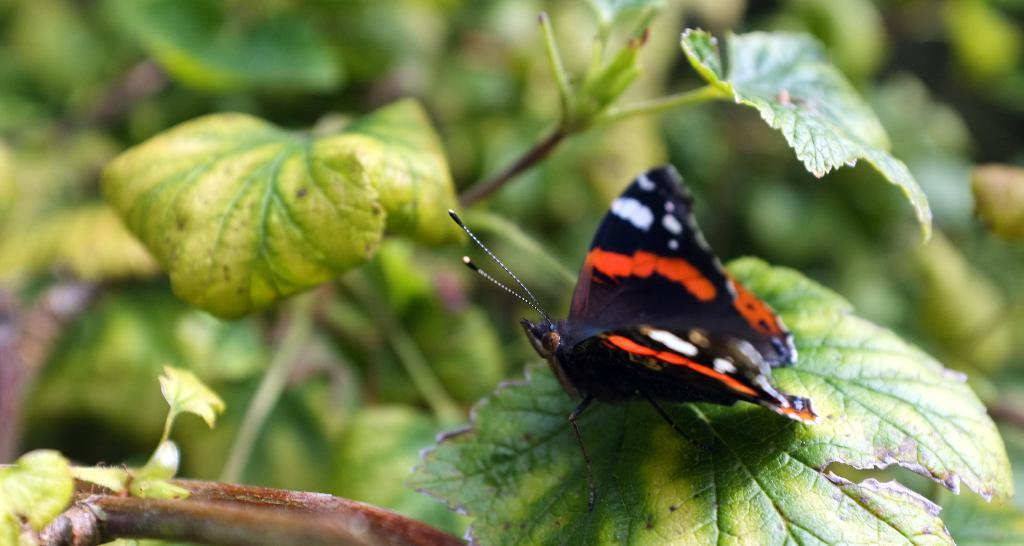What is on the leaf in the image? There is a butterfly on a leaf in the image. What can be seen in the background of the image? There are plants visible in the background of the image. What type of yarn is being used to create the cars in the image? There are no cars or yarn present in the image; it features a butterfly on a leaf and plants in the background. 